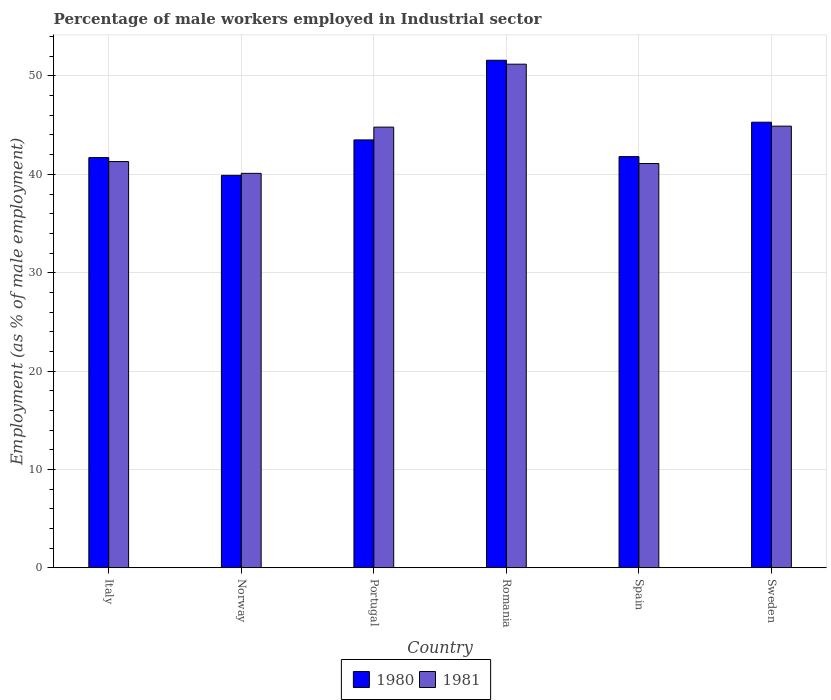How many groups of bars are there?
Offer a terse response. 6. Are the number of bars per tick equal to the number of legend labels?
Provide a succinct answer. Yes. Are the number of bars on each tick of the X-axis equal?
Offer a terse response. Yes. How many bars are there on the 2nd tick from the left?
Your answer should be compact. 2. How many bars are there on the 4th tick from the right?
Provide a succinct answer. 2. What is the label of the 1st group of bars from the left?
Give a very brief answer. Italy. In how many cases, is the number of bars for a given country not equal to the number of legend labels?
Your answer should be very brief. 0. What is the percentage of male workers employed in Industrial sector in 1981 in Sweden?
Ensure brevity in your answer.  44.9. Across all countries, what is the maximum percentage of male workers employed in Industrial sector in 1981?
Provide a succinct answer. 51.2. Across all countries, what is the minimum percentage of male workers employed in Industrial sector in 1980?
Your response must be concise. 39.9. In which country was the percentage of male workers employed in Industrial sector in 1981 maximum?
Give a very brief answer. Romania. In which country was the percentage of male workers employed in Industrial sector in 1981 minimum?
Your answer should be very brief. Norway. What is the total percentage of male workers employed in Industrial sector in 1981 in the graph?
Your answer should be compact. 263.4. What is the difference between the percentage of male workers employed in Industrial sector in 1980 in Norway and that in Spain?
Make the answer very short. -1.9. What is the difference between the percentage of male workers employed in Industrial sector in 1981 in Norway and the percentage of male workers employed in Industrial sector in 1980 in Italy?
Make the answer very short. -1.6. What is the average percentage of male workers employed in Industrial sector in 1981 per country?
Provide a short and direct response. 43.9. What is the difference between the percentage of male workers employed in Industrial sector of/in 1981 and percentage of male workers employed in Industrial sector of/in 1980 in Norway?
Your response must be concise. 0.2. In how many countries, is the percentage of male workers employed in Industrial sector in 1980 greater than 18 %?
Provide a short and direct response. 6. What is the ratio of the percentage of male workers employed in Industrial sector in 1981 in Romania to that in Sweden?
Your answer should be very brief. 1.14. Is the percentage of male workers employed in Industrial sector in 1981 in Romania less than that in Spain?
Offer a terse response. No. Is the difference between the percentage of male workers employed in Industrial sector in 1981 in Romania and Spain greater than the difference between the percentage of male workers employed in Industrial sector in 1980 in Romania and Spain?
Offer a very short reply. Yes. What is the difference between the highest and the second highest percentage of male workers employed in Industrial sector in 1981?
Provide a short and direct response. 6.3. What is the difference between the highest and the lowest percentage of male workers employed in Industrial sector in 1981?
Your response must be concise. 11.1. How many bars are there?
Offer a very short reply. 12. Are all the bars in the graph horizontal?
Provide a succinct answer. No. Are the values on the major ticks of Y-axis written in scientific E-notation?
Your response must be concise. No. How many legend labels are there?
Offer a very short reply. 2. How are the legend labels stacked?
Provide a short and direct response. Horizontal. What is the title of the graph?
Ensure brevity in your answer.  Percentage of male workers employed in Industrial sector. Does "1965" appear as one of the legend labels in the graph?
Your answer should be compact. No. What is the label or title of the X-axis?
Offer a very short reply. Country. What is the label or title of the Y-axis?
Your response must be concise. Employment (as % of male employment). What is the Employment (as % of male employment) in 1980 in Italy?
Offer a terse response. 41.7. What is the Employment (as % of male employment) in 1981 in Italy?
Make the answer very short. 41.3. What is the Employment (as % of male employment) in 1980 in Norway?
Provide a short and direct response. 39.9. What is the Employment (as % of male employment) in 1981 in Norway?
Offer a terse response. 40.1. What is the Employment (as % of male employment) of 1980 in Portugal?
Your answer should be very brief. 43.5. What is the Employment (as % of male employment) in 1981 in Portugal?
Offer a very short reply. 44.8. What is the Employment (as % of male employment) of 1980 in Romania?
Give a very brief answer. 51.6. What is the Employment (as % of male employment) in 1981 in Romania?
Your answer should be compact. 51.2. What is the Employment (as % of male employment) of 1980 in Spain?
Give a very brief answer. 41.8. What is the Employment (as % of male employment) in 1981 in Spain?
Provide a succinct answer. 41.1. What is the Employment (as % of male employment) in 1980 in Sweden?
Provide a succinct answer. 45.3. What is the Employment (as % of male employment) in 1981 in Sweden?
Your response must be concise. 44.9. Across all countries, what is the maximum Employment (as % of male employment) in 1980?
Offer a very short reply. 51.6. Across all countries, what is the maximum Employment (as % of male employment) in 1981?
Ensure brevity in your answer.  51.2. Across all countries, what is the minimum Employment (as % of male employment) in 1980?
Give a very brief answer. 39.9. Across all countries, what is the minimum Employment (as % of male employment) of 1981?
Offer a very short reply. 40.1. What is the total Employment (as % of male employment) of 1980 in the graph?
Your answer should be very brief. 263.8. What is the total Employment (as % of male employment) in 1981 in the graph?
Offer a terse response. 263.4. What is the difference between the Employment (as % of male employment) in 1980 in Italy and that in Portugal?
Provide a short and direct response. -1.8. What is the difference between the Employment (as % of male employment) of 1981 in Italy and that in Portugal?
Your answer should be very brief. -3.5. What is the difference between the Employment (as % of male employment) of 1981 in Italy and that in Spain?
Your answer should be very brief. 0.2. What is the difference between the Employment (as % of male employment) in 1980 in Norway and that in Portugal?
Make the answer very short. -3.6. What is the difference between the Employment (as % of male employment) of 1980 in Norway and that in Romania?
Give a very brief answer. -11.7. What is the difference between the Employment (as % of male employment) in 1980 in Norway and that in Spain?
Your answer should be compact. -1.9. What is the difference between the Employment (as % of male employment) of 1981 in Norway and that in Spain?
Ensure brevity in your answer.  -1. What is the difference between the Employment (as % of male employment) in 1981 in Norway and that in Sweden?
Make the answer very short. -4.8. What is the difference between the Employment (as % of male employment) in 1980 in Portugal and that in Romania?
Keep it short and to the point. -8.1. What is the difference between the Employment (as % of male employment) in 1981 in Portugal and that in Romania?
Make the answer very short. -6.4. What is the difference between the Employment (as % of male employment) of 1980 in Portugal and that in Spain?
Keep it short and to the point. 1.7. What is the difference between the Employment (as % of male employment) of 1980 in Portugal and that in Sweden?
Your answer should be very brief. -1.8. What is the difference between the Employment (as % of male employment) in 1981 in Portugal and that in Sweden?
Your answer should be very brief. -0.1. What is the difference between the Employment (as % of male employment) in 1980 in Romania and that in Sweden?
Give a very brief answer. 6.3. What is the difference between the Employment (as % of male employment) of 1980 in Italy and the Employment (as % of male employment) of 1981 in Portugal?
Ensure brevity in your answer.  -3.1. What is the difference between the Employment (as % of male employment) in 1980 in Italy and the Employment (as % of male employment) in 1981 in Romania?
Ensure brevity in your answer.  -9.5. What is the difference between the Employment (as % of male employment) in 1980 in Italy and the Employment (as % of male employment) in 1981 in Sweden?
Keep it short and to the point. -3.2. What is the difference between the Employment (as % of male employment) of 1980 in Norway and the Employment (as % of male employment) of 1981 in Romania?
Your answer should be compact. -11.3. What is the difference between the Employment (as % of male employment) of 1980 in Norway and the Employment (as % of male employment) of 1981 in Sweden?
Give a very brief answer. -5. What is the difference between the Employment (as % of male employment) in 1980 in Portugal and the Employment (as % of male employment) in 1981 in Romania?
Provide a succinct answer. -7.7. What is the difference between the Employment (as % of male employment) in 1980 in Portugal and the Employment (as % of male employment) in 1981 in Spain?
Offer a terse response. 2.4. What is the difference between the Employment (as % of male employment) of 1980 in Portugal and the Employment (as % of male employment) of 1981 in Sweden?
Provide a succinct answer. -1.4. What is the difference between the Employment (as % of male employment) of 1980 in Romania and the Employment (as % of male employment) of 1981 in Sweden?
Keep it short and to the point. 6.7. What is the difference between the Employment (as % of male employment) in 1980 in Spain and the Employment (as % of male employment) in 1981 in Sweden?
Offer a very short reply. -3.1. What is the average Employment (as % of male employment) in 1980 per country?
Keep it short and to the point. 43.97. What is the average Employment (as % of male employment) in 1981 per country?
Your answer should be compact. 43.9. What is the difference between the Employment (as % of male employment) in 1980 and Employment (as % of male employment) in 1981 in Norway?
Your answer should be compact. -0.2. What is the difference between the Employment (as % of male employment) of 1980 and Employment (as % of male employment) of 1981 in Romania?
Provide a short and direct response. 0.4. What is the difference between the Employment (as % of male employment) in 1980 and Employment (as % of male employment) in 1981 in Spain?
Your response must be concise. 0.7. What is the difference between the Employment (as % of male employment) of 1980 and Employment (as % of male employment) of 1981 in Sweden?
Offer a very short reply. 0.4. What is the ratio of the Employment (as % of male employment) in 1980 in Italy to that in Norway?
Offer a very short reply. 1.05. What is the ratio of the Employment (as % of male employment) of 1981 in Italy to that in Norway?
Make the answer very short. 1.03. What is the ratio of the Employment (as % of male employment) in 1980 in Italy to that in Portugal?
Your answer should be compact. 0.96. What is the ratio of the Employment (as % of male employment) of 1981 in Italy to that in Portugal?
Provide a succinct answer. 0.92. What is the ratio of the Employment (as % of male employment) in 1980 in Italy to that in Romania?
Your answer should be compact. 0.81. What is the ratio of the Employment (as % of male employment) in 1981 in Italy to that in Romania?
Provide a succinct answer. 0.81. What is the ratio of the Employment (as % of male employment) of 1981 in Italy to that in Spain?
Give a very brief answer. 1. What is the ratio of the Employment (as % of male employment) of 1980 in Italy to that in Sweden?
Your response must be concise. 0.92. What is the ratio of the Employment (as % of male employment) in 1981 in Italy to that in Sweden?
Your response must be concise. 0.92. What is the ratio of the Employment (as % of male employment) in 1980 in Norway to that in Portugal?
Offer a very short reply. 0.92. What is the ratio of the Employment (as % of male employment) in 1981 in Norway to that in Portugal?
Offer a very short reply. 0.9. What is the ratio of the Employment (as % of male employment) of 1980 in Norway to that in Romania?
Your response must be concise. 0.77. What is the ratio of the Employment (as % of male employment) of 1981 in Norway to that in Romania?
Ensure brevity in your answer.  0.78. What is the ratio of the Employment (as % of male employment) of 1980 in Norway to that in Spain?
Offer a very short reply. 0.95. What is the ratio of the Employment (as % of male employment) in 1981 in Norway to that in Spain?
Your response must be concise. 0.98. What is the ratio of the Employment (as % of male employment) of 1980 in Norway to that in Sweden?
Your response must be concise. 0.88. What is the ratio of the Employment (as % of male employment) of 1981 in Norway to that in Sweden?
Provide a succinct answer. 0.89. What is the ratio of the Employment (as % of male employment) of 1980 in Portugal to that in Romania?
Make the answer very short. 0.84. What is the ratio of the Employment (as % of male employment) of 1980 in Portugal to that in Spain?
Provide a succinct answer. 1.04. What is the ratio of the Employment (as % of male employment) of 1981 in Portugal to that in Spain?
Your answer should be compact. 1.09. What is the ratio of the Employment (as % of male employment) of 1980 in Portugal to that in Sweden?
Provide a succinct answer. 0.96. What is the ratio of the Employment (as % of male employment) of 1981 in Portugal to that in Sweden?
Ensure brevity in your answer.  1. What is the ratio of the Employment (as % of male employment) of 1980 in Romania to that in Spain?
Your response must be concise. 1.23. What is the ratio of the Employment (as % of male employment) in 1981 in Romania to that in Spain?
Your response must be concise. 1.25. What is the ratio of the Employment (as % of male employment) in 1980 in Romania to that in Sweden?
Offer a very short reply. 1.14. What is the ratio of the Employment (as % of male employment) in 1981 in Romania to that in Sweden?
Provide a succinct answer. 1.14. What is the ratio of the Employment (as % of male employment) of 1980 in Spain to that in Sweden?
Offer a very short reply. 0.92. What is the ratio of the Employment (as % of male employment) of 1981 in Spain to that in Sweden?
Your answer should be compact. 0.92. What is the difference between the highest and the lowest Employment (as % of male employment) in 1981?
Your answer should be compact. 11.1. 